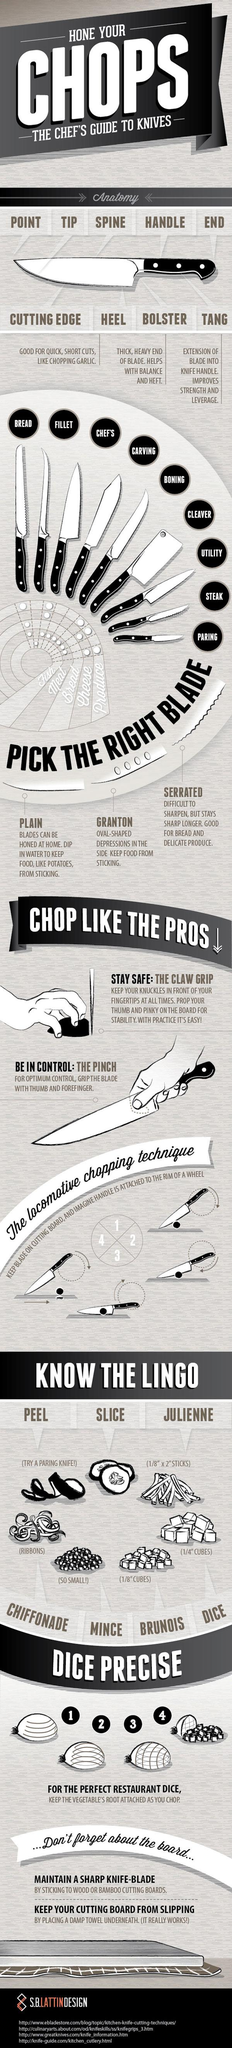Identify some key points in this picture. Granton blade is the one that prevents food from sticking to it. The term "Brunoise" refers to 1/8 cubes. 